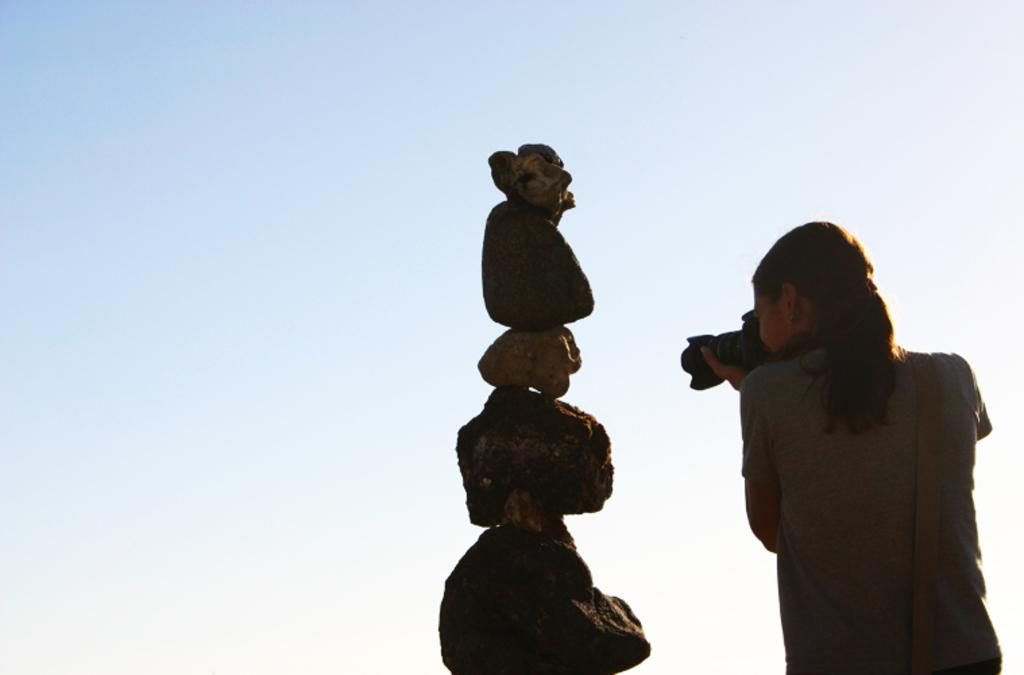What is the main subject of the image? The main subject of the image is a woman. What is the woman holding in her hands? The woman is holding a camera in her hands. What type of natural elements can be seen in the image? There are stones visible in the image. What is visible in the background of the image? The sky is visible in the image. What type of waste can be seen scattered around the woman in the image? There is no waste visible in the image; it is a clean scene with the woman holding a camera. Can you tell me how many knives are visible in the image? There are no knives present in the image. 